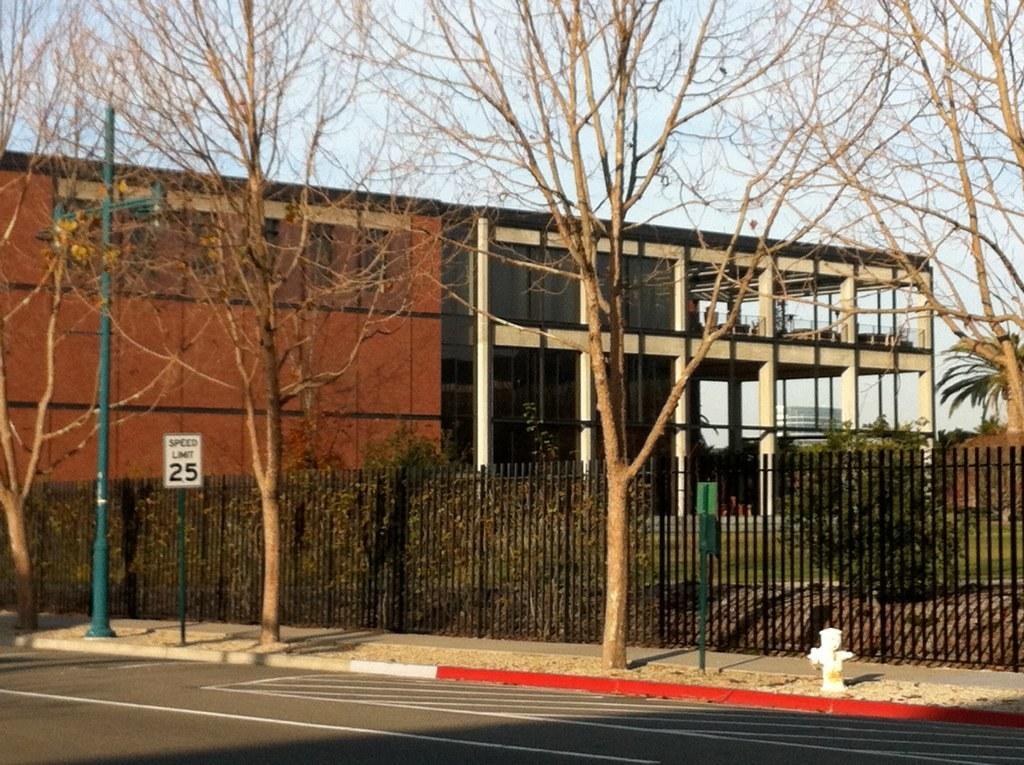How would you summarize this image in a sentence or two? In the image in the center we can see trees,plants,grass,poles,sign board,fence,road and water pole. In the background we can see the sky,wall,clouds,buildings and pillars. 